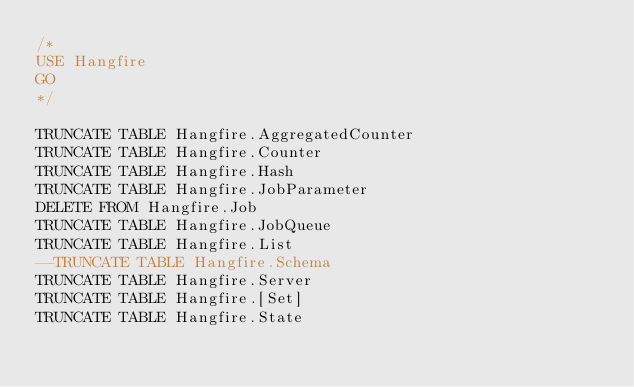Convert code to text. <code><loc_0><loc_0><loc_500><loc_500><_SQL_>/*
USE Hangfire
GO
*/

TRUNCATE TABLE Hangfire.AggregatedCounter
TRUNCATE TABLE Hangfire.Counter
TRUNCATE TABLE Hangfire.Hash
TRUNCATE TABLE Hangfire.JobParameter
DELETE FROM Hangfire.Job
TRUNCATE TABLE Hangfire.JobQueue
TRUNCATE TABLE Hangfire.List
--TRUNCATE TABLE Hangfire.Schema
TRUNCATE TABLE Hangfire.Server
TRUNCATE TABLE Hangfire.[Set]
TRUNCATE TABLE Hangfire.State
</code> 